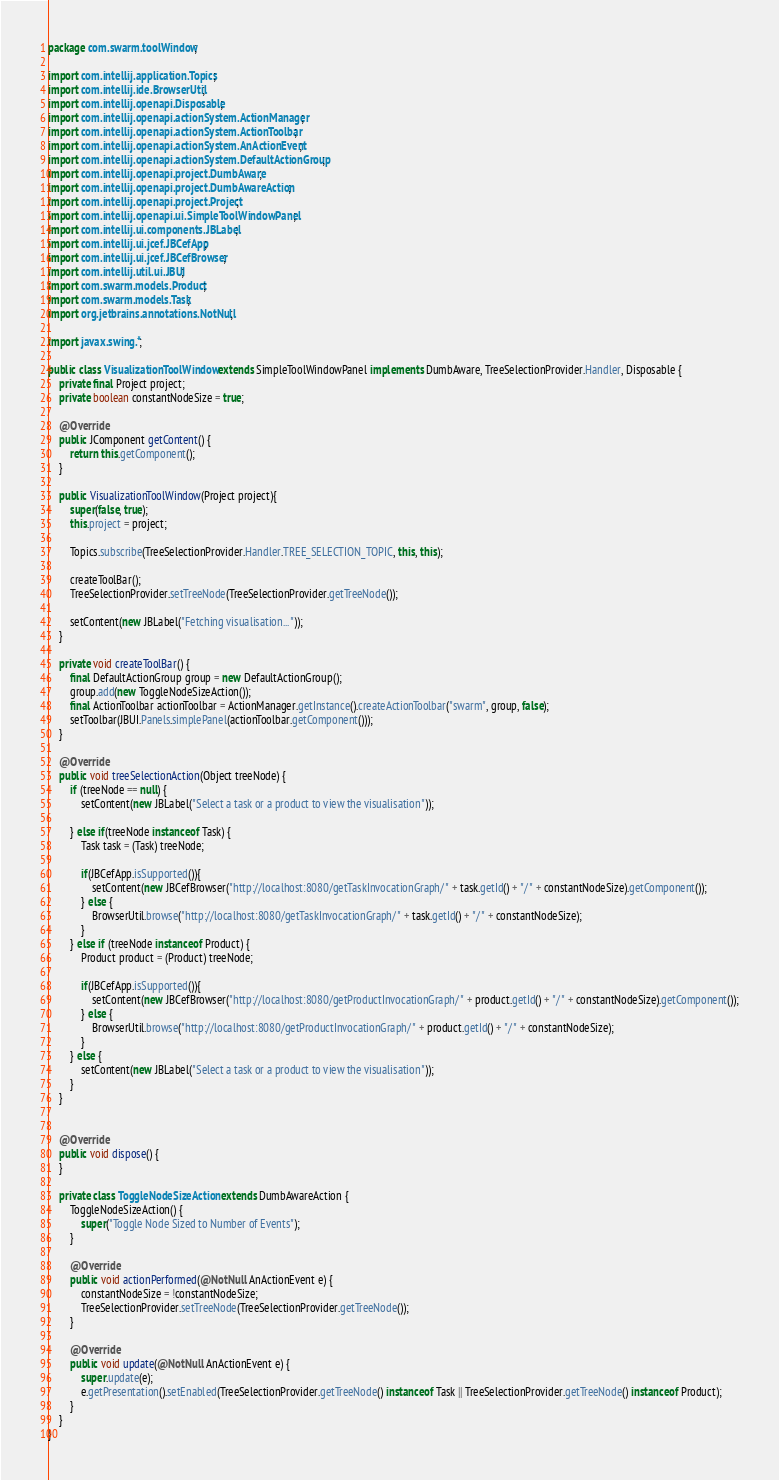<code> <loc_0><loc_0><loc_500><loc_500><_Java_>package com.swarm.toolWindow;

import com.intellij.application.Topics;
import com.intellij.ide.BrowserUtil;
import com.intellij.openapi.Disposable;
import com.intellij.openapi.actionSystem.ActionManager;
import com.intellij.openapi.actionSystem.ActionToolbar;
import com.intellij.openapi.actionSystem.AnActionEvent;
import com.intellij.openapi.actionSystem.DefaultActionGroup;
import com.intellij.openapi.project.DumbAware;
import com.intellij.openapi.project.DumbAwareAction;
import com.intellij.openapi.project.Project;
import com.intellij.openapi.ui.SimpleToolWindowPanel;
import com.intellij.ui.components.JBLabel;
import com.intellij.ui.jcef.JBCefApp;
import com.intellij.ui.jcef.JBCefBrowser;
import com.intellij.util.ui.JBUI;
import com.swarm.models.Product;
import com.swarm.models.Task;
import org.jetbrains.annotations.NotNull;

import javax.swing.*;

public class VisualizationToolWindow extends SimpleToolWindowPanel implements DumbAware, TreeSelectionProvider.Handler, Disposable {
    private final Project project;
    private boolean constantNodeSize = true;

    @Override
    public JComponent getContent() {
        return this.getComponent();
    }

    public VisualizationToolWindow(Project project){
        super(false, true);
        this.project = project;

        Topics.subscribe(TreeSelectionProvider.Handler.TREE_SELECTION_TOPIC, this, this);

        createToolBar();
        TreeSelectionProvider.setTreeNode(TreeSelectionProvider.getTreeNode());

        setContent(new JBLabel("Fetching visualisation..."));
    }

    private void createToolBar() {
        final DefaultActionGroup group = new DefaultActionGroup();
        group.add(new ToggleNodeSizeAction());
        final ActionToolbar actionToolbar = ActionManager.getInstance().createActionToolbar("swarm", group, false);
        setToolbar(JBUI.Panels.simplePanel(actionToolbar.getComponent()));
    }

    @Override
    public void treeSelectionAction(Object treeNode) {
        if (treeNode == null) {
            setContent(new JBLabel("Select a task or a product to view the visualisation"));

        } else if(treeNode instanceof Task) {
            Task task = (Task) treeNode;

            if(JBCefApp.isSupported()){
                setContent(new JBCefBrowser("http://localhost:8080/getTaskInvocationGraph/" + task.getId() + "/" + constantNodeSize).getComponent());
            } else {
                BrowserUtil.browse("http://localhost:8080/getTaskInvocationGraph/" + task.getId() + "/" + constantNodeSize);
            }
        } else if (treeNode instanceof Product) {
            Product product = (Product) treeNode;

            if(JBCefApp.isSupported()){
                setContent(new JBCefBrowser("http://localhost:8080/getProductInvocationGraph/" + product.getId() + "/" + constantNodeSize).getComponent());
            } else {
                BrowserUtil.browse("http://localhost:8080/getProductInvocationGraph/" + product.getId() + "/" + constantNodeSize);
            }
        } else {
            setContent(new JBLabel("Select a task or a product to view the visualisation"));
        }
    }


    @Override
    public void dispose() {
    }

    private class ToggleNodeSizeAction extends DumbAwareAction {
        ToggleNodeSizeAction() {
            super("Toggle Node Sized to Number of Events");
        }

        @Override
        public void actionPerformed(@NotNull AnActionEvent e) {
            constantNodeSize = !constantNodeSize;
            TreeSelectionProvider.setTreeNode(TreeSelectionProvider.getTreeNode());
        }

        @Override
        public void update(@NotNull AnActionEvent e) {
            super.update(e);
            e.getPresentation().setEnabled(TreeSelectionProvider.getTreeNode() instanceof Task || TreeSelectionProvider.getTreeNode() instanceof Product);
        }
    }
}
</code> 